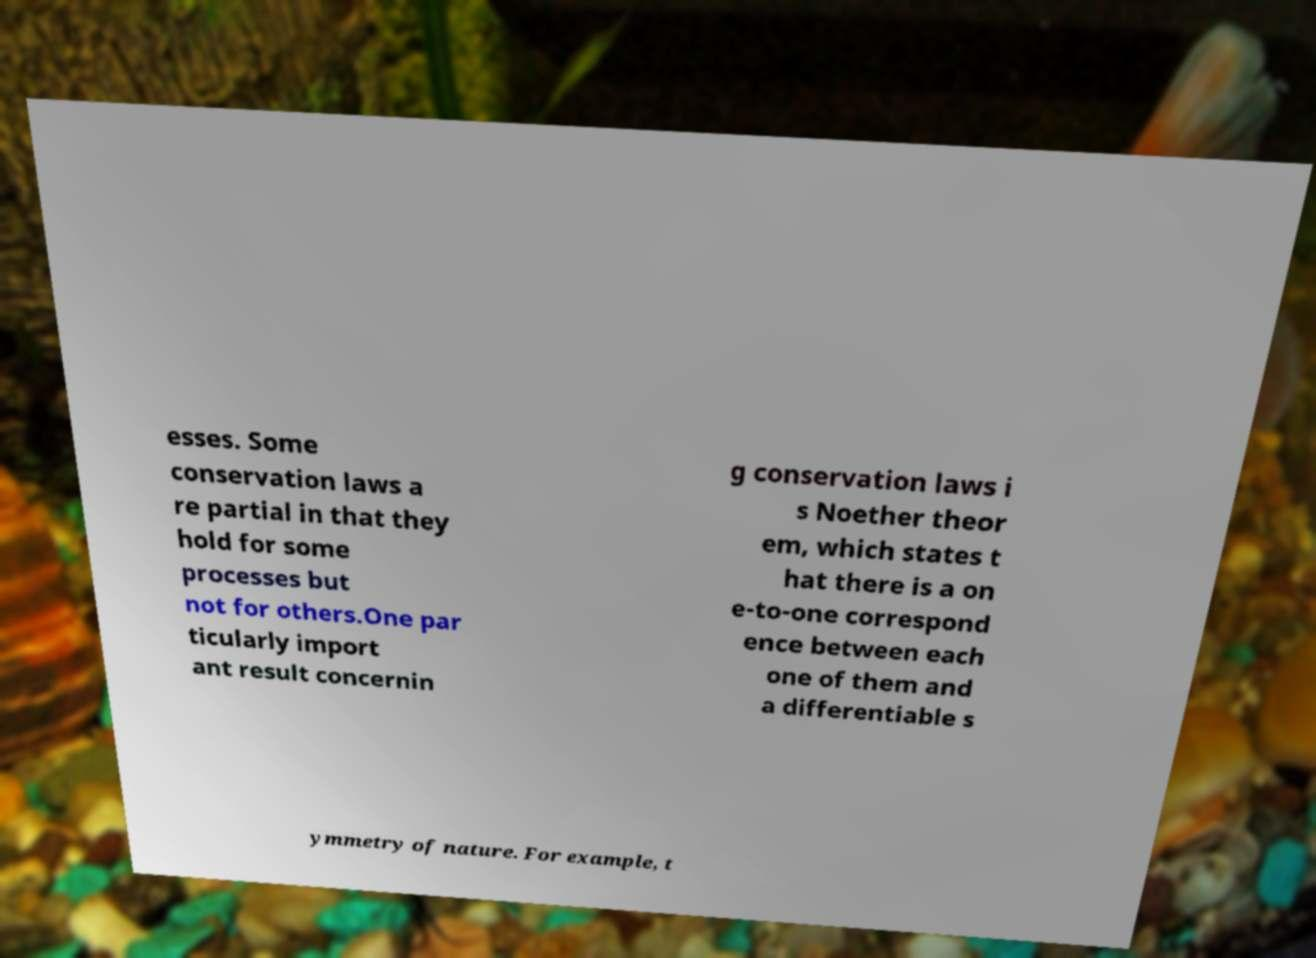Could you extract and type out the text from this image? esses. Some conservation laws a re partial in that they hold for some processes but not for others.One par ticularly import ant result concernin g conservation laws i s Noether theor em, which states t hat there is a on e-to-one correspond ence between each one of them and a differentiable s ymmetry of nature. For example, t 